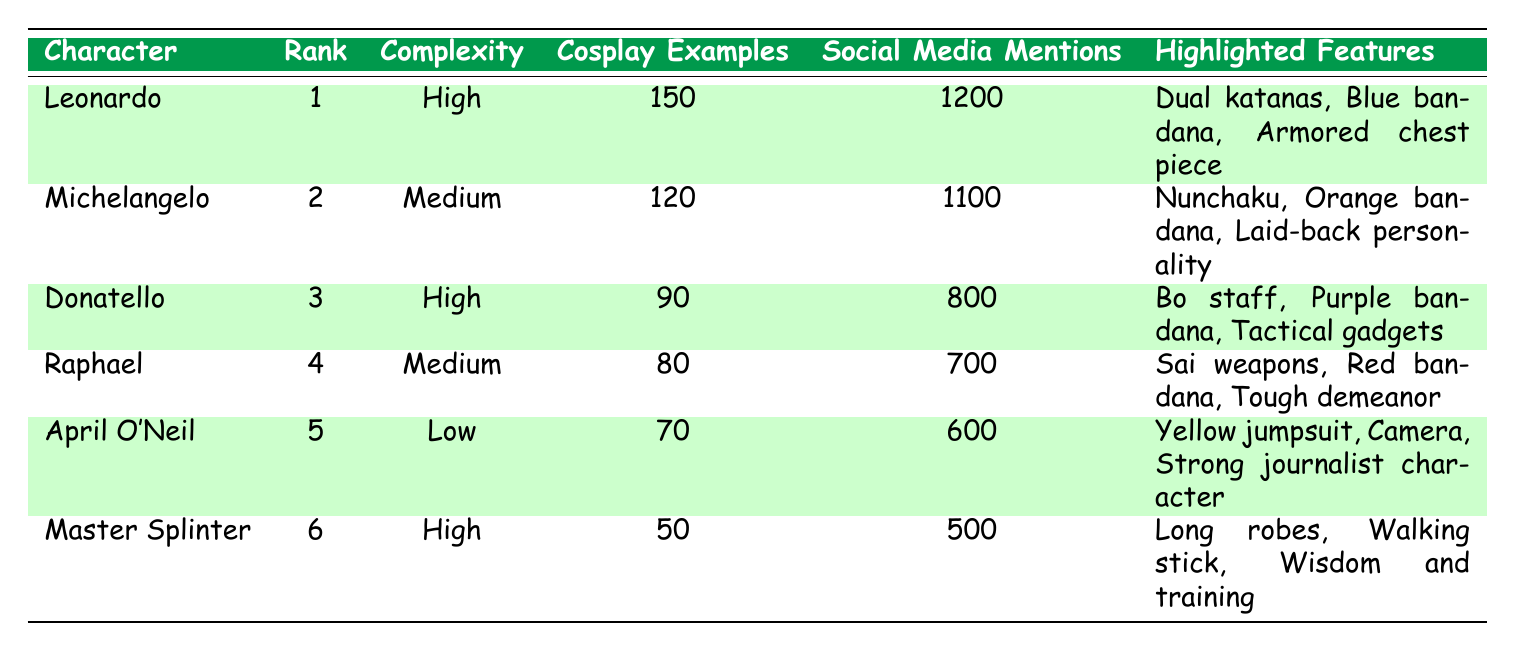What's the popularity rank of Michelangelo? Michelangelo is listed with a popularity rank in the second column of the table, where it indicates his rank as 2.
Answer: 2 Which character has the highest number of cosplay examples? Comparing the values in the "Cosplay Examples" column, Leonardo has the highest at 150 examples, more than any other character.
Answer: Leonardo How many social media mentions does Donatello have? The table shows that Donatello has 800 mentions in the "Social Media Mentions" column.
Answer: 800 Is April O'Neil's costume complexity classified as high? In the "Complexity" column, April O'Neil is listed with a "Low" complexity, so the answer is no.
Answer: No What is the total number of fan cosplay examples for all characters? Adding the cosplay examples: 150 (Leonardo) + 120 (Michelangelo) + 90 (Donatello) + 80 (Raphael) + 70 (April O'Neil) + 50 (Master Splinter) equals 560.
Answer: 560 Which character has a higher number of social media mentions, Donatello or Raphael? Donatello has 800 mentions while Raphael has 700, so Donatello has more mentions.
Answer: Donatello What is the average number of cosplay examples for the characters? Summing the cosplay examples (150 + 120 + 90 + 80 + 70 + 50 = 560) yields 560 divided by 6 characters equals approximately 93.33.
Answer: 93.33 Which character features the dual katanas as highlighted features? The table shows that Leonardo is noted for having dual katanas as part of his highlighted features.
Answer: Leonardo What is the difference in the number of social media mentions between Michelangelo and Master Splinter? Michelangelo has 1100 mentions and Master Splinter has 500; the difference is 1100 - 500 = 600.
Answer: 600 Using the complexity ratings, how many characters have high complexity costumes? The table highlights Leonardo, Donatello, and Master Splinter as having "High" complexity. Therefore, there are three characters with high complexity costumes.
Answer: 3 